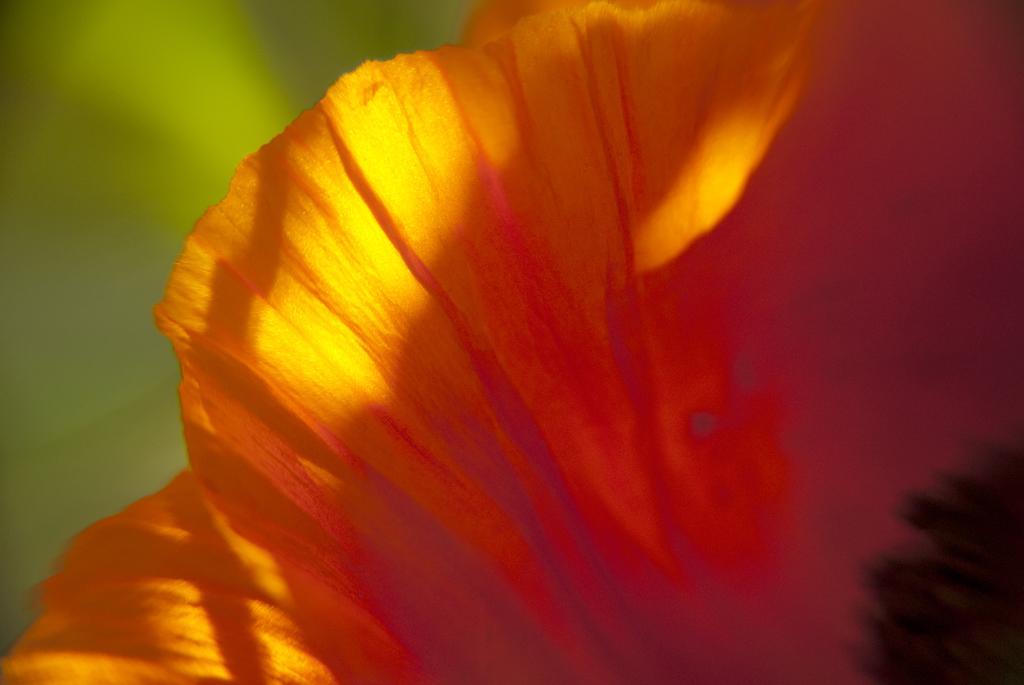Can you describe this image briefly? In this picture, we can see a flower which is in orange color. On the left side, we can also see green color. 